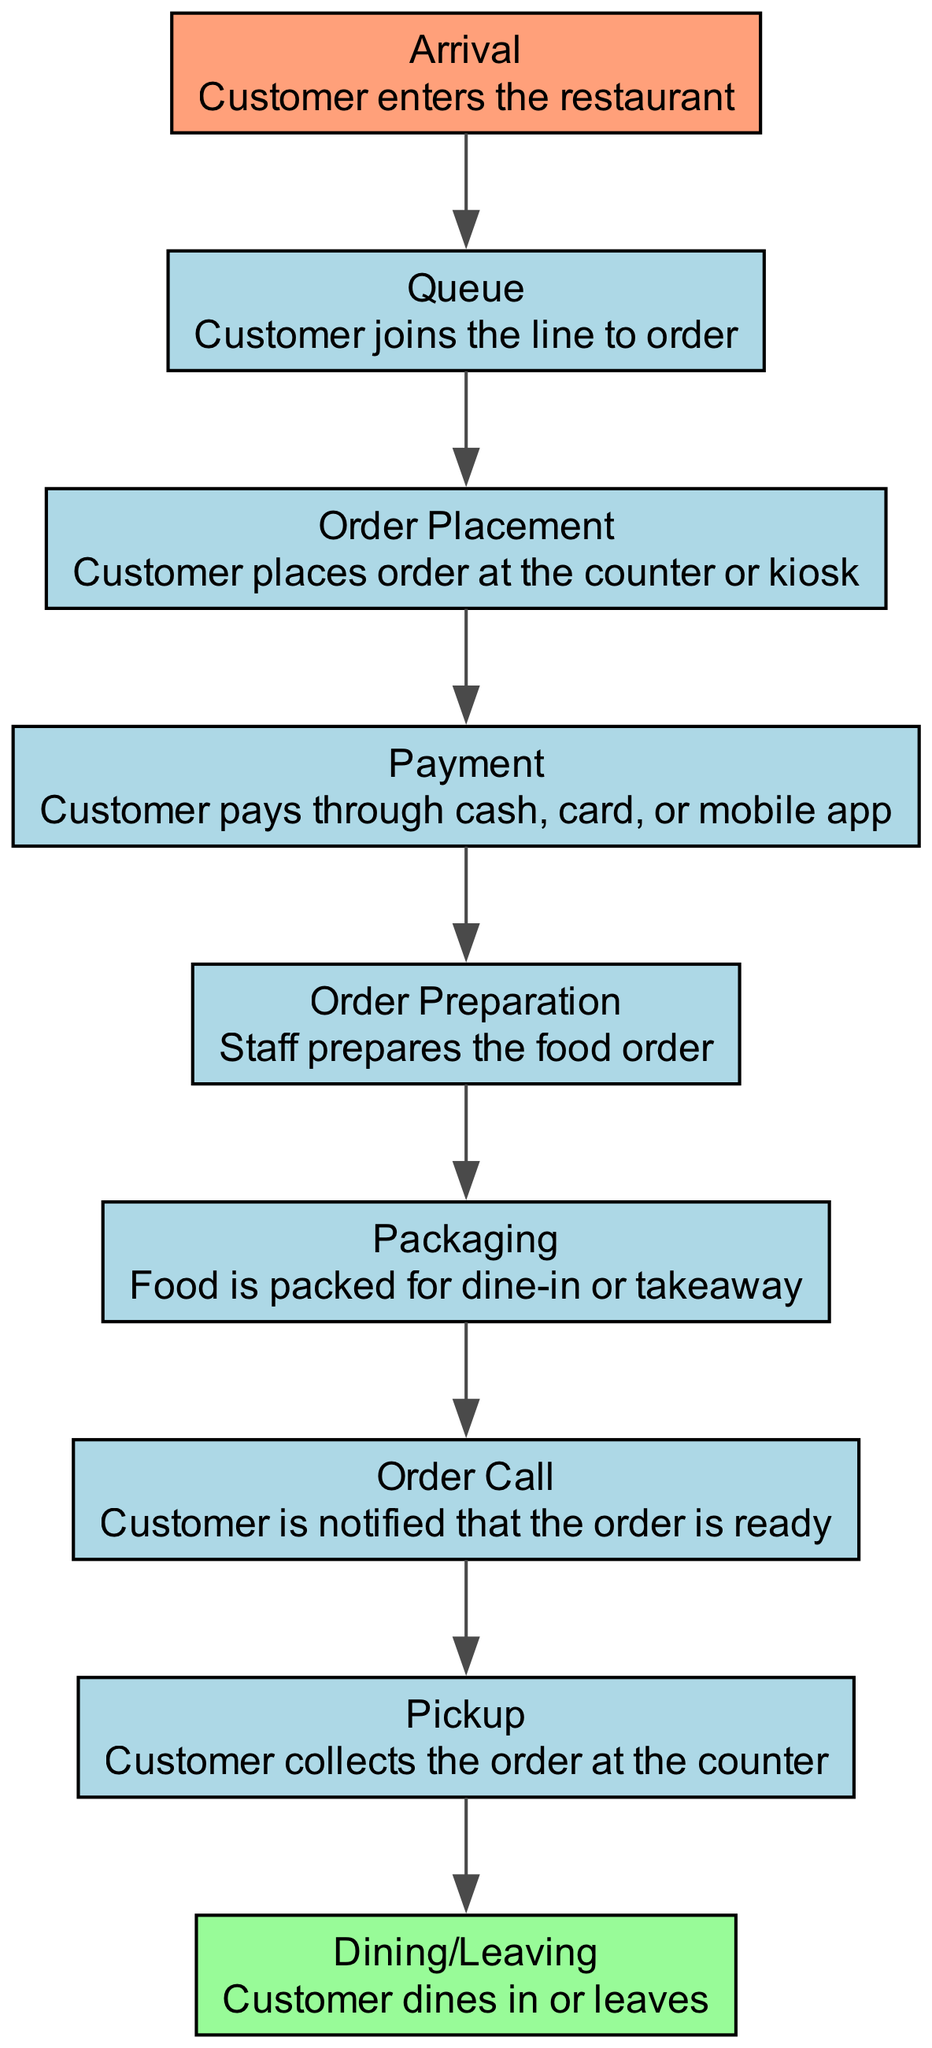What is the first step in the customer flow? The first step in the customer flow, as displayed in the diagram, is "Arrival," indicating that the customer enters the restaurant.
Answer: Arrival How many steps are there in the customer flow? Counting each step in the diagram from "Arrival" to "Dining/Leaving," there are a total of 9 steps in the customer flow.
Answer: 9 What follows after "Payment" in the customer flow? The step that follows "Payment" is "Order Preparation," indicating that staff prepares the food order after payment is completed.
Answer: Order Preparation Which step has a description involving notifying the customer? The step that includes notifying the customer is "Order Call," where the customer is informed that the order is ready.
Answer: Order Call What is the last step in the customer journey? The last step in the customer journey is "Dining/Leaving," which signifies that the customer either dines in the restaurant or leaves with takeaway.
Answer: Dining/Leaving If a customer is in the "Queue" step, what step comes next? After the "Queue" step, the next step is "Order Placement," where the customer places their order at the counter or kiosk.
Answer: Order Placement What step involves payment methods? The step that involves payment methods is "Payment," where customers can pay through cash, card, or mobile app.
Answer: Payment Which step is represented with a light blue background indicating it is a starting point? The step represented with a light blue background as the starting point is "Arrival," highlighting the beginning of the customer journey in the restaurant.
Answer: Arrival What do customers do in the "Pickup" step? In the "Pickup" step, customers collect the order at the counter after being notified that it is ready.
Answer: Collects the order 